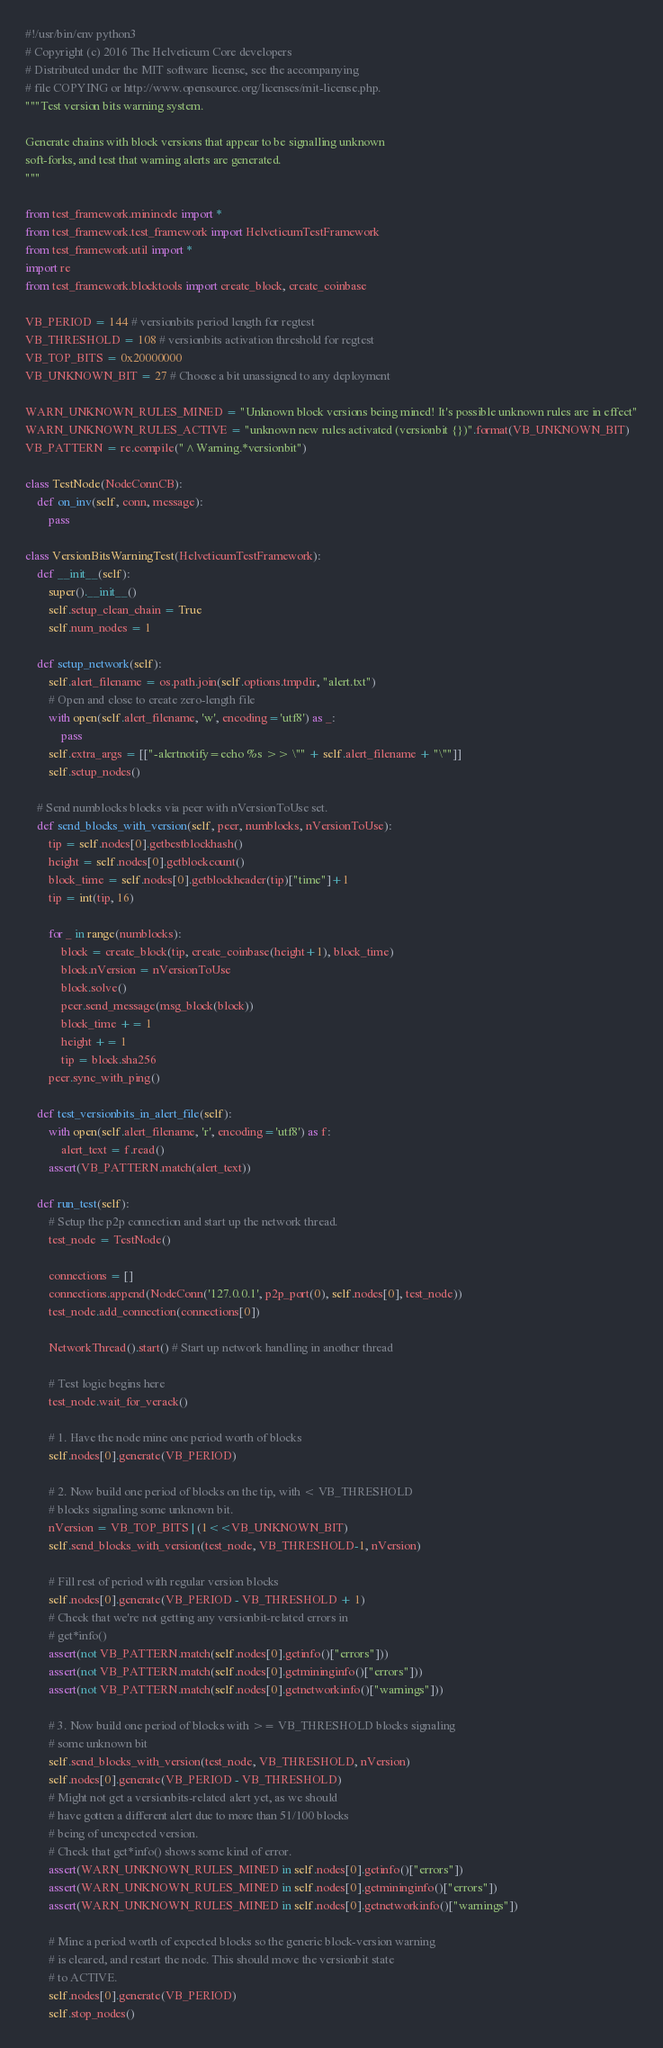Convert code to text. <code><loc_0><loc_0><loc_500><loc_500><_Python_>#!/usr/bin/env python3
# Copyright (c) 2016 The Helveticum Core developers
# Distributed under the MIT software license, see the accompanying
# file COPYING or http://www.opensource.org/licenses/mit-license.php.
"""Test version bits warning system.

Generate chains with block versions that appear to be signalling unknown
soft-forks, and test that warning alerts are generated.
"""

from test_framework.mininode import *
from test_framework.test_framework import HelveticumTestFramework
from test_framework.util import *
import re
from test_framework.blocktools import create_block, create_coinbase

VB_PERIOD = 144 # versionbits period length for regtest
VB_THRESHOLD = 108 # versionbits activation threshold for regtest
VB_TOP_BITS = 0x20000000
VB_UNKNOWN_BIT = 27 # Choose a bit unassigned to any deployment

WARN_UNKNOWN_RULES_MINED = "Unknown block versions being mined! It's possible unknown rules are in effect"
WARN_UNKNOWN_RULES_ACTIVE = "unknown new rules activated (versionbit {})".format(VB_UNKNOWN_BIT)
VB_PATTERN = re.compile("^Warning.*versionbit")

class TestNode(NodeConnCB):
    def on_inv(self, conn, message):
        pass

class VersionBitsWarningTest(HelveticumTestFramework):
    def __init__(self):
        super().__init__()
        self.setup_clean_chain = True
        self.num_nodes = 1

    def setup_network(self):
        self.alert_filename = os.path.join(self.options.tmpdir, "alert.txt")
        # Open and close to create zero-length file
        with open(self.alert_filename, 'w', encoding='utf8') as _:
            pass
        self.extra_args = [["-alertnotify=echo %s >> \"" + self.alert_filename + "\""]]
        self.setup_nodes()

    # Send numblocks blocks via peer with nVersionToUse set.
    def send_blocks_with_version(self, peer, numblocks, nVersionToUse):
        tip = self.nodes[0].getbestblockhash()
        height = self.nodes[0].getblockcount()
        block_time = self.nodes[0].getblockheader(tip)["time"]+1
        tip = int(tip, 16)

        for _ in range(numblocks):
            block = create_block(tip, create_coinbase(height+1), block_time)
            block.nVersion = nVersionToUse
            block.solve()
            peer.send_message(msg_block(block))
            block_time += 1
            height += 1
            tip = block.sha256
        peer.sync_with_ping()

    def test_versionbits_in_alert_file(self):
        with open(self.alert_filename, 'r', encoding='utf8') as f:
            alert_text = f.read()
        assert(VB_PATTERN.match(alert_text))

    def run_test(self):
        # Setup the p2p connection and start up the network thread.
        test_node = TestNode()

        connections = []
        connections.append(NodeConn('127.0.0.1', p2p_port(0), self.nodes[0], test_node))
        test_node.add_connection(connections[0])

        NetworkThread().start() # Start up network handling in another thread

        # Test logic begins here
        test_node.wait_for_verack()

        # 1. Have the node mine one period worth of blocks
        self.nodes[0].generate(VB_PERIOD)

        # 2. Now build one period of blocks on the tip, with < VB_THRESHOLD
        # blocks signaling some unknown bit.
        nVersion = VB_TOP_BITS | (1<<VB_UNKNOWN_BIT)
        self.send_blocks_with_version(test_node, VB_THRESHOLD-1, nVersion)

        # Fill rest of period with regular version blocks
        self.nodes[0].generate(VB_PERIOD - VB_THRESHOLD + 1)
        # Check that we're not getting any versionbit-related errors in
        # get*info()
        assert(not VB_PATTERN.match(self.nodes[0].getinfo()["errors"]))
        assert(not VB_PATTERN.match(self.nodes[0].getmininginfo()["errors"]))
        assert(not VB_PATTERN.match(self.nodes[0].getnetworkinfo()["warnings"]))

        # 3. Now build one period of blocks with >= VB_THRESHOLD blocks signaling
        # some unknown bit
        self.send_blocks_with_version(test_node, VB_THRESHOLD, nVersion)
        self.nodes[0].generate(VB_PERIOD - VB_THRESHOLD)
        # Might not get a versionbits-related alert yet, as we should
        # have gotten a different alert due to more than 51/100 blocks
        # being of unexpected version.
        # Check that get*info() shows some kind of error.
        assert(WARN_UNKNOWN_RULES_MINED in self.nodes[0].getinfo()["errors"])
        assert(WARN_UNKNOWN_RULES_MINED in self.nodes[0].getmininginfo()["errors"])
        assert(WARN_UNKNOWN_RULES_MINED in self.nodes[0].getnetworkinfo()["warnings"])

        # Mine a period worth of expected blocks so the generic block-version warning
        # is cleared, and restart the node. This should move the versionbit state
        # to ACTIVE.
        self.nodes[0].generate(VB_PERIOD)
        self.stop_nodes()</code> 